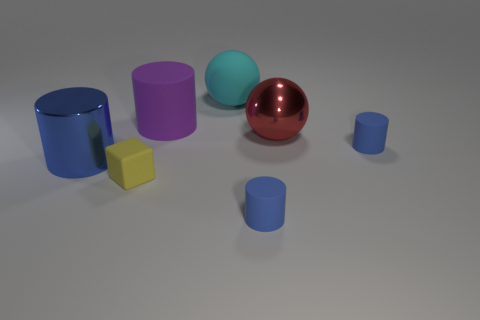Subtract all brown blocks. How many blue cylinders are left? 3 Subtract all cyan cylinders. Subtract all purple blocks. How many cylinders are left? 4 Add 1 gray rubber objects. How many objects exist? 8 Subtract all balls. How many objects are left? 5 Add 5 small blue matte things. How many small blue matte things exist? 7 Subtract 1 cyan spheres. How many objects are left? 6 Subtract all large gray metallic objects. Subtract all big cyan matte things. How many objects are left? 6 Add 3 large cylinders. How many large cylinders are left? 5 